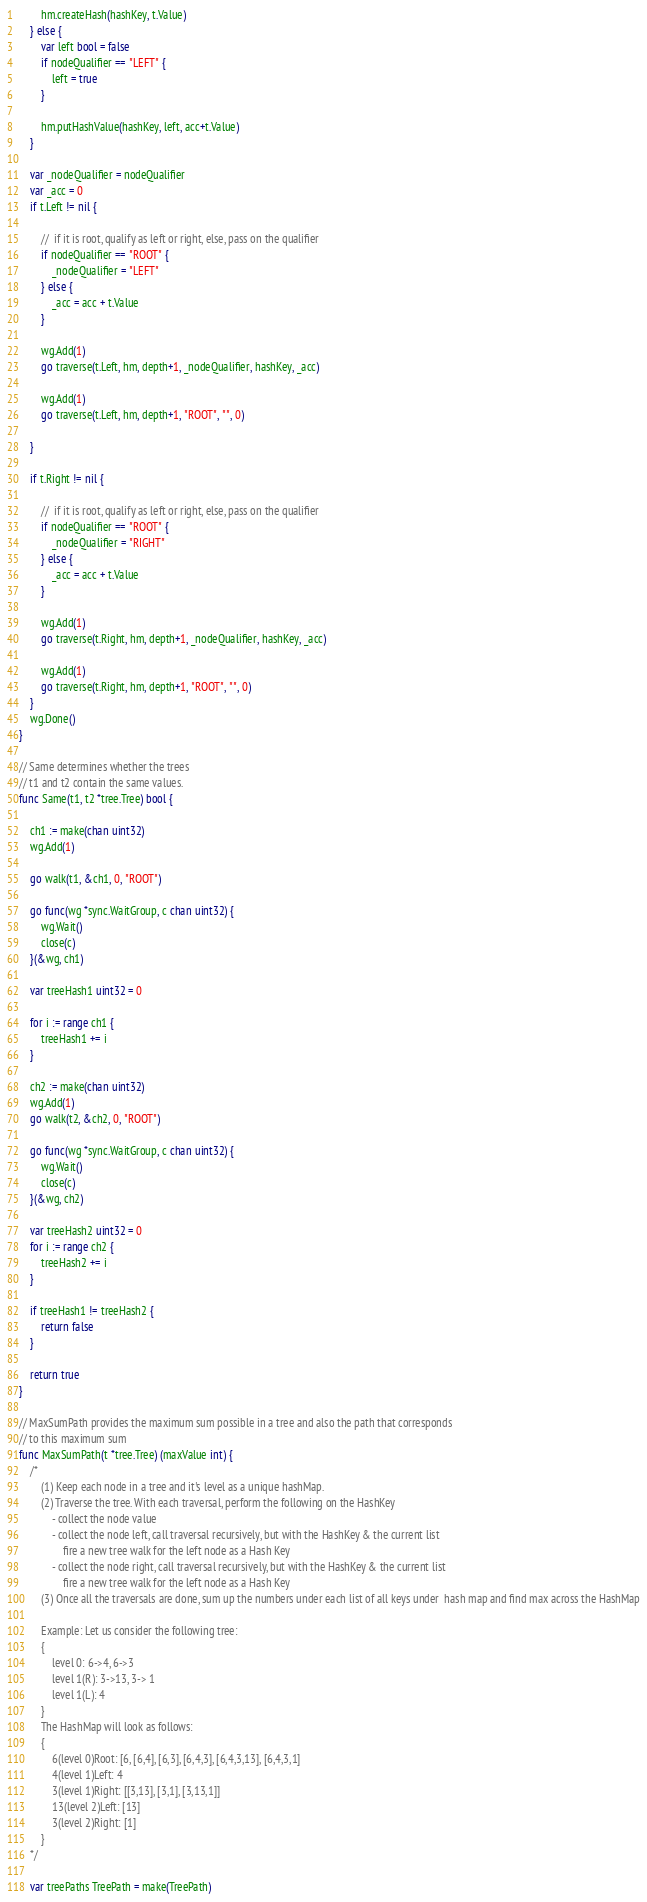<code> <loc_0><loc_0><loc_500><loc_500><_Go_>		hm.createHash(hashKey, t.Value)
	} else {
		var left bool = false
		if nodeQualifier == "LEFT" {
			left = true
		}

		hm.putHashValue(hashKey, left, acc+t.Value)
	}

	var _nodeQualifier = nodeQualifier
	var _acc = 0
	if t.Left != nil {

		//  if it is root, qualify as left or right, else, pass on the qualifier
		if nodeQualifier == "ROOT" {
			_nodeQualifier = "LEFT"
		} else {
			_acc = acc + t.Value
		}

		wg.Add(1)
		go traverse(t.Left, hm, depth+1, _nodeQualifier, hashKey, _acc)

		wg.Add(1)
		go traverse(t.Left, hm, depth+1, "ROOT", "", 0)

	}

	if t.Right != nil {

		//  if it is root, qualify as left or right, else, pass on the qualifier
		if nodeQualifier == "ROOT" {
			_nodeQualifier = "RIGHT"
		} else {
			_acc = acc + t.Value
		}

		wg.Add(1)
		go traverse(t.Right, hm, depth+1, _nodeQualifier, hashKey, _acc)

		wg.Add(1)
		go traverse(t.Right, hm, depth+1, "ROOT", "", 0)
	}
	wg.Done()
}

// Same determines whether the trees
// t1 and t2 contain the same values.
func Same(t1, t2 *tree.Tree) bool {

	ch1 := make(chan uint32)
	wg.Add(1)

	go walk(t1, &ch1, 0, "ROOT")

	go func(wg *sync.WaitGroup, c chan uint32) {
		wg.Wait()
		close(c)
	}(&wg, ch1)

	var treeHash1 uint32 = 0

	for i := range ch1 {
		treeHash1 += i
	}

	ch2 := make(chan uint32)
	wg.Add(1)
	go walk(t2, &ch2, 0, "ROOT")

	go func(wg *sync.WaitGroup, c chan uint32) {
		wg.Wait()
		close(c)
	}(&wg, ch2)

	var treeHash2 uint32 = 0
	for i := range ch2 {
		treeHash2 += i
	}

	if treeHash1 != treeHash2 {
		return false
	}

	return true
}

// MaxSumPath provides the maximum sum possible in a tree and also the path that corresponds
// to this maximum sum
func MaxSumPath(t *tree.Tree) (maxValue int) {
	/*
		(1) Keep each node in a tree and it's level as a unique hashMap.
		(2) Traverse the tree. With each traversal, perform the following on the HashKey
			- collect the node value
			- collect the node left, call traversal recursively, but with the HashKey & the current list
				fire a new tree walk for the left node as a Hash Key
			- collect the node right, call traversal recursively, but with the HashKey & the current list
				fire a new tree walk for the left node as a Hash Key
		(3) Once all the traversals are done, sum up the numbers under each list of all keys under  hash map and find max across the HashMap

		Example: Let us consider the following tree:
		{
			level 0: 6->4, 6->3
			level 1(R): 3->13, 3-> 1
			level 1(L): 4
		}
		The HashMap will look as follows:
		{
			6(level 0)Root: [6, [6,4], [6,3], [6,4,3], [6,4,3,13], [6,4,3,1]
			4(level 1)Left: 4
			3(level 1)Right: [[3,13], [3,1], [3,13,1]]
			13(level 2)Left: [13]
			3(level 2)Right: [1]
		}
	*/

	var treePaths TreePath = make(TreePath)
</code> 